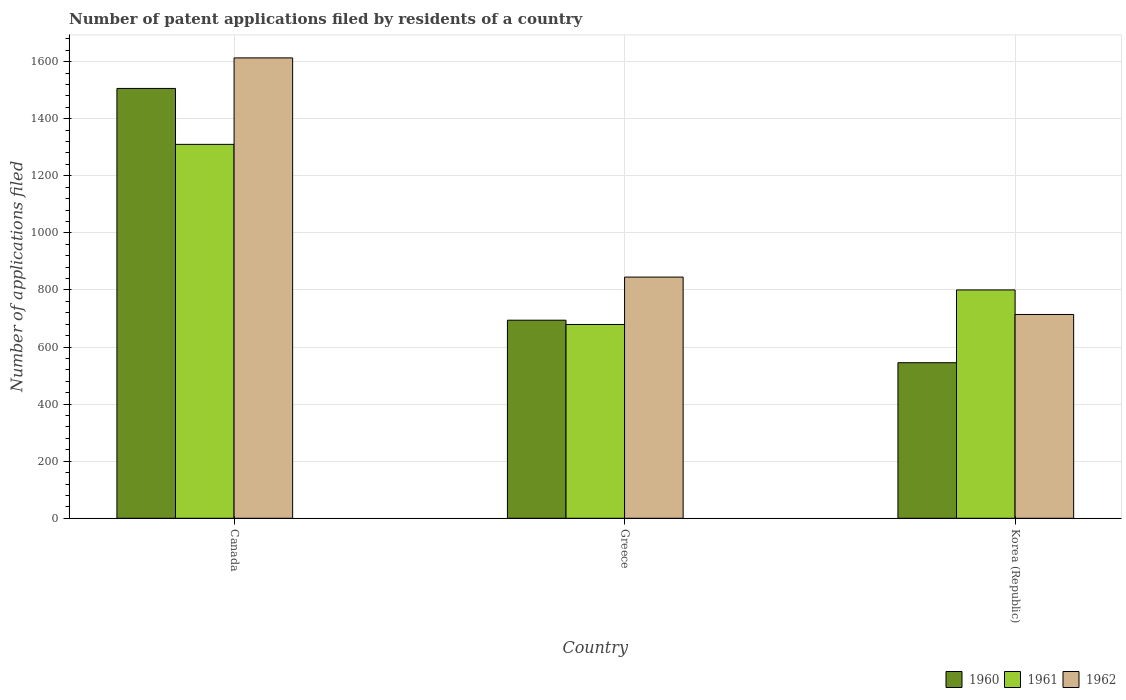How many groups of bars are there?
Keep it short and to the point. 3. Are the number of bars on each tick of the X-axis equal?
Provide a succinct answer. Yes. How many bars are there on the 1st tick from the left?
Offer a very short reply. 3. How many bars are there on the 1st tick from the right?
Offer a very short reply. 3. What is the label of the 1st group of bars from the left?
Offer a terse response. Canada. What is the number of applications filed in 1960 in Canada?
Keep it short and to the point. 1506. Across all countries, what is the maximum number of applications filed in 1962?
Keep it short and to the point. 1613. Across all countries, what is the minimum number of applications filed in 1961?
Provide a succinct answer. 679. What is the total number of applications filed in 1960 in the graph?
Make the answer very short. 2745. What is the difference between the number of applications filed in 1960 in Canada and that in Greece?
Your answer should be very brief. 812. What is the difference between the number of applications filed in 1960 in Korea (Republic) and the number of applications filed in 1962 in Canada?
Your answer should be compact. -1068. What is the average number of applications filed in 1960 per country?
Make the answer very short. 915. What is the difference between the number of applications filed of/in 1960 and number of applications filed of/in 1961 in Korea (Republic)?
Make the answer very short. -255. In how many countries, is the number of applications filed in 1960 greater than 1040?
Give a very brief answer. 1. What is the ratio of the number of applications filed in 1960 in Canada to that in Korea (Republic)?
Your answer should be very brief. 2.76. Is the number of applications filed in 1962 in Canada less than that in Greece?
Your response must be concise. No. Is the difference between the number of applications filed in 1960 in Greece and Korea (Republic) greater than the difference between the number of applications filed in 1961 in Greece and Korea (Republic)?
Offer a very short reply. Yes. What is the difference between the highest and the second highest number of applications filed in 1960?
Ensure brevity in your answer.  -961. What is the difference between the highest and the lowest number of applications filed in 1960?
Make the answer very short. 961. In how many countries, is the number of applications filed in 1960 greater than the average number of applications filed in 1960 taken over all countries?
Provide a short and direct response. 1. What does the 1st bar from the left in Korea (Republic) represents?
Provide a short and direct response. 1960. What does the 2nd bar from the right in Canada represents?
Your response must be concise. 1961. Is it the case that in every country, the sum of the number of applications filed in 1960 and number of applications filed in 1962 is greater than the number of applications filed in 1961?
Provide a succinct answer. Yes. How many countries are there in the graph?
Give a very brief answer. 3. Are the values on the major ticks of Y-axis written in scientific E-notation?
Make the answer very short. No. Does the graph contain any zero values?
Your answer should be compact. No. Does the graph contain grids?
Make the answer very short. Yes. How are the legend labels stacked?
Offer a terse response. Horizontal. What is the title of the graph?
Your response must be concise. Number of patent applications filed by residents of a country. What is the label or title of the Y-axis?
Offer a very short reply. Number of applications filed. What is the Number of applications filed of 1960 in Canada?
Offer a very short reply. 1506. What is the Number of applications filed of 1961 in Canada?
Ensure brevity in your answer.  1310. What is the Number of applications filed in 1962 in Canada?
Your response must be concise. 1613. What is the Number of applications filed of 1960 in Greece?
Your answer should be compact. 694. What is the Number of applications filed of 1961 in Greece?
Provide a short and direct response. 679. What is the Number of applications filed in 1962 in Greece?
Your answer should be compact. 845. What is the Number of applications filed of 1960 in Korea (Republic)?
Offer a terse response. 545. What is the Number of applications filed of 1961 in Korea (Republic)?
Give a very brief answer. 800. What is the Number of applications filed in 1962 in Korea (Republic)?
Make the answer very short. 714. Across all countries, what is the maximum Number of applications filed in 1960?
Make the answer very short. 1506. Across all countries, what is the maximum Number of applications filed in 1961?
Ensure brevity in your answer.  1310. Across all countries, what is the maximum Number of applications filed in 1962?
Provide a succinct answer. 1613. Across all countries, what is the minimum Number of applications filed of 1960?
Offer a very short reply. 545. Across all countries, what is the minimum Number of applications filed of 1961?
Keep it short and to the point. 679. Across all countries, what is the minimum Number of applications filed in 1962?
Your response must be concise. 714. What is the total Number of applications filed in 1960 in the graph?
Provide a short and direct response. 2745. What is the total Number of applications filed of 1961 in the graph?
Make the answer very short. 2789. What is the total Number of applications filed of 1962 in the graph?
Offer a terse response. 3172. What is the difference between the Number of applications filed of 1960 in Canada and that in Greece?
Provide a succinct answer. 812. What is the difference between the Number of applications filed of 1961 in Canada and that in Greece?
Provide a short and direct response. 631. What is the difference between the Number of applications filed of 1962 in Canada and that in Greece?
Your answer should be very brief. 768. What is the difference between the Number of applications filed in 1960 in Canada and that in Korea (Republic)?
Offer a very short reply. 961. What is the difference between the Number of applications filed of 1961 in Canada and that in Korea (Republic)?
Provide a short and direct response. 510. What is the difference between the Number of applications filed in 1962 in Canada and that in Korea (Republic)?
Give a very brief answer. 899. What is the difference between the Number of applications filed of 1960 in Greece and that in Korea (Republic)?
Make the answer very short. 149. What is the difference between the Number of applications filed in 1961 in Greece and that in Korea (Republic)?
Offer a terse response. -121. What is the difference between the Number of applications filed in 1962 in Greece and that in Korea (Republic)?
Ensure brevity in your answer.  131. What is the difference between the Number of applications filed of 1960 in Canada and the Number of applications filed of 1961 in Greece?
Offer a terse response. 827. What is the difference between the Number of applications filed of 1960 in Canada and the Number of applications filed of 1962 in Greece?
Provide a succinct answer. 661. What is the difference between the Number of applications filed in 1961 in Canada and the Number of applications filed in 1962 in Greece?
Provide a short and direct response. 465. What is the difference between the Number of applications filed of 1960 in Canada and the Number of applications filed of 1961 in Korea (Republic)?
Keep it short and to the point. 706. What is the difference between the Number of applications filed of 1960 in Canada and the Number of applications filed of 1962 in Korea (Republic)?
Your answer should be very brief. 792. What is the difference between the Number of applications filed of 1961 in Canada and the Number of applications filed of 1962 in Korea (Republic)?
Offer a terse response. 596. What is the difference between the Number of applications filed in 1960 in Greece and the Number of applications filed in 1961 in Korea (Republic)?
Keep it short and to the point. -106. What is the difference between the Number of applications filed of 1960 in Greece and the Number of applications filed of 1962 in Korea (Republic)?
Your response must be concise. -20. What is the difference between the Number of applications filed of 1961 in Greece and the Number of applications filed of 1962 in Korea (Republic)?
Your answer should be compact. -35. What is the average Number of applications filed of 1960 per country?
Your answer should be compact. 915. What is the average Number of applications filed in 1961 per country?
Your answer should be very brief. 929.67. What is the average Number of applications filed in 1962 per country?
Provide a short and direct response. 1057.33. What is the difference between the Number of applications filed in 1960 and Number of applications filed in 1961 in Canada?
Keep it short and to the point. 196. What is the difference between the Number of applications filed in 1960 and Number of applications filed in 1962 in Canada?
Your answer should be very brief. -107. What is the difference between the Number of applications filed of 1961 and Number of applications filed of 1962 in Canada?
Keep it short and to the point. -303. What is the difference between the Number of applications filed in 1960 and Number of applications filed in 1961 in Greece?
Your response must be concise. 15. What is the difference between the Number of applications filed of 1960 and Number of applications filed of 1962 in Greece?
Keep it short and to the point. -151. What is the difference between the Number of applications filed in 1961 and Number of applications filed in 1962 in Greece?
Make the answer very short. -166. What is the difference between the Number of applications filed of 1960 and Number of applications filed of 1961 in Korea (Republic)?
Offer a terse response. -255. What is the difference between the Number of applications filed of 1960 and Number of applications filed of 1962 in Korea (Republic)?
Keep it short and to the point. -169. What is the ratio of the Number of applications filed of 1960 in Canada to that in Greece?
Keep it short and to the point. 2.17. What is the ratio of the Number of applications filed in 1961 in Canada to that in Greece?
Ensure brevity in your answer.  1.93. What is the ratio of the Number of applications filed of 1962 in Canada to that in Greece?
Ensure brevity in your answer.  1.91. What is the ratio of the Number of applications filed of 1960 in Canada to that in Korea (Republic)?
Your answer should be very brief. 2.76. What is the ratio of the Number of applications filed of 1961 in Canada to that in Korea (Republic)?
Give a very brief answer. 1.64. What is the ratio of the Number of applications filed of 1962 in Canada to that in Korea (Republic)?
Your answer should be very brief. 2.26. What is the ratio of the Number of applications filed in 1960 in Greece to that in Korea (Republic)?
Make the answer very short. 1.27. What is the ratio of the Number of applications filed of 1961 in Greece to that in Korea (Republic)?
Provide a short and direct response. 0.85. What is the ratio of the Number of applications filed of 1962 in Greece to that in Korea (Republic)?
Your response must be concise. 1.18. What is the difference between the highest and the second highest Number of applications filed in 1960?
Make the answer very short. 812. What is the difference between the highest and the second highest Number of applications filed of 1961?
Make the answer very short. 510. What is the difference between the highest and the second highest Number of applications filed of 1962?
Offer a terse response. 768. What is the difference between the highest and the lowest Number of applications filed in 1960?
Keep it short and to the point. 961. What is the difference between the highest and the lowest Number of applications filed in 1961?
Provide a succinct answer. 631. What is the difference between the highest and the lowest Number of applications filed in 1962?
Give a very brief answer. 899. 